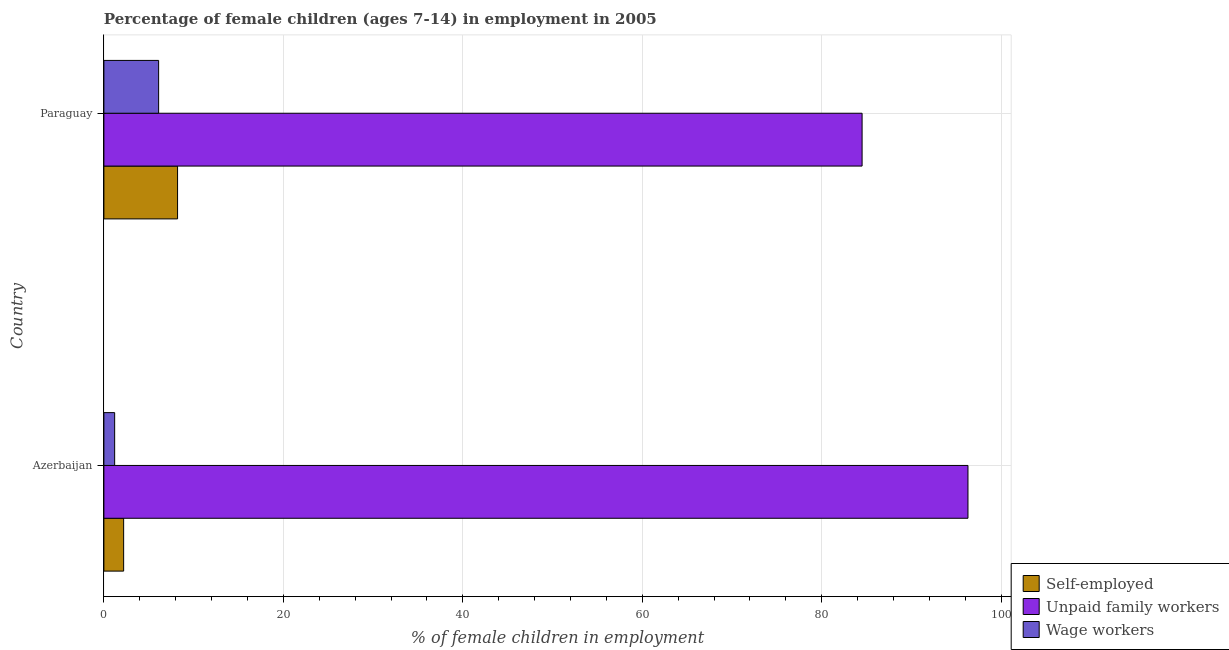How many different coloured bars are there?
Offer a very short reply. 3. How many groups of bars are there?
Keep it short and to the point. 2. Are the number of bars per tick equal to the number of legend labels?
Give a very brief answer. Yes. Are the number of bars on each tick of the Y-axis equal?
Provide a short and direct response. Yes. How many bars are there on the 1st tick from the bottom?
Your answer should be compact. 3. What is the label of the 2nd group of bars from the top?
Offer a very short reply. Azerbaijan. In how many cases, is the number of bars for a given country not equal to the number of legend labels?
Your answer should be compact. 0. What is the percentage of children employed as unpaid family workers in Azerbaijan?
Offer a very short reply. 96.3. Across all countries, what is the maximum percentage of children employed as unpaid family workers?
Make the answer very short. 96.3. Across all countries, what is the minimum percentage of children employed as unpaid family workers?
Provide a succinct answer. 84.5. In which country was the percentage of children employed as wage workers maximum?
Keep it short and to the point. Paraguay. In which country was the percentage of children employed as unpaid family workers minimum?
Offer a terse response. Paraguay. What is the difference between the percentage of self employed children in Azerbaijan and that in Paraguay?
Ensure brevity in your answer.  -6.01. What is the difference between the percentage of children employed as unpaid family workers in Azerbaijan and the percentage of children employed as wage workers in Paraguay?
Your response must be concise. 90.2. What is the average percentage of children employed as unpaid family workers per country?
Give a very brief answer. 90.4. What is the difference between the percentage of children employed as unpaid family workers and percentage of children employed as wage workers in Paraguay?
Your answer should be very brief. 78.4. In how many countries, is the percentage of self employed children greater than 48 %?
Provide a short and direct response. 0. What is the ratio of the percentage of children employed as wage workers in Azerbaijan to that in Paraguay?
Give a very brief answer. 0.2. Is the percentage of self employed children in Azerbaijan less than that in Paraguay?
Give a very brief answer. Yes. Is the difference between the percentage of self employed children in Azerbaijan and Paraguay greater than the difference between the percentage of children employed as unpaid family workers in Azerbaijan and Paraguay?
Offer a very short reply. No. In how many countries, is the percentage of children employed as wage workers greater than the average percentage of children employed as wage workers taken over all countries?
Provide a succinct answer. 1. What does the 3rd bar from the top in Azerbaijan represents?
Give a very brief answer. Self-employed. What does the 1st bar from the bottom in Paraguay represents?
Your response must be concise. Self-employed. How many bars are there?
Your answer should be compact. 6. Are all the bars in the graph horizontal?
Your answer should be compact. Yes. How many countries are there in the graph?
Ensure brevity in your answer.  2. Are the values on the major ticks of X-axis written in scientific E-notation?
Your answer should be compact. No. Does the graph contain any zero values?
Ensure brevity in your answer.  No. Does the graph contain grids?
Give a very brief answer. Yes. Where does the legend appear in the graph?
Give a very brief answer. Bottom right. How many legend labels are there?
Your answer should be compact. 3. How are the legend labels stacked?
Offer a very short reply. Vertical. What is the title of the graph?
Provide a short and direct response. Percentage of female children (ages 7-14) in employment in 2005. What is the label or title of the X-axis?
Give a very brief answer. % of female children in employment. What is the % of female children in employment in Unpaid family workers in Azerbaijan?
Your answer should be compact. 96.3. What is the % of female children in employment in Wage workers in Azerbaijan?
Make the answer very short. 1.2. What is the % of female children in employment of Self-employed in Paraguay?
Offer a terse response. 8.21. What is the % of female children in employment of Unpaid family workers in Paraguay?
Your answer should be compact. 84.5. What is the % of female children in employment in Wage workers in Paraguay?
Your answer should be very brief. 6.1. Across all countries, what is the maximum % of female children in employment of Self-employed?
Offer a terse response. 8.21. Across all countries, what is the maximum % of female children in employment in Unpaid family workers?
Give a very brief answer. 96.3. Across all countries, what is the minimum % of female children in employment of Self-employed?
Provide a succinct answer. 2.2. Across all countries, what is the minimum % of female children in employment of Unpaid family workers?
Offer a very short reply. 84.5. What is the total % of female children in employment of Self-employed in the graph?
Provide a short and direct response. 10.41. What is the total % of female children in employment in Unpaid family workers in the graph?
Keep it short and to the point. 180.8. What is the difference between the % of female children in employment in Self-employed in Azerbaijan and that in Paraguay?
Offer a very short reply. -6.01. What is the difference between the % of female children in employment of Unpaid family workers in Azerbaijan and that in Paraguay?
Ensure brevity in your answer.  11.8. What is the difference between the % of female children in employment of Wage workers in Azerbaijan and that in Paraguay?
Offer a terse response. -4.9. What is the difference between the % of female children in employment of Self-employed in Azerbaijan and the % of female children in employment of Unpaid family workers in Paraguay?
Offer a very short reply. -82.3. What is the difference between the % of female children in employment in Unpaid family workers in Azerbaijan and the % of female children in employment in Wage workers in Paraguay?
Your answer should be compact. 90.2. What is the average % of female children in employment in Self-employed per country?
Provide a succinct answer. 5.21. What is the average % of female children in employment in Unpaid family workers per country?
Your answer should be compact. 90.4. What is the average % of female children in employment of Wage workers per country?
Offer a terse response. 3.65. What is the difference between the % of female children in employment of Self-employed and % of female children in employment of Unpaid family workers in Azerbaijan?
Give a very brief answer. -94.1. What is the difference between the % of female children in employment of Unpaid family workers and % of female children in employment of Wage workers in Azerbaijan?
Provide a short and direct response. 95.1. What is the difference between the % of female children in employment in Self-employed and % of female children in employment in Unpaid family workers in Paraguay?
Keep it short and to the point. -76.29. What is the difference between the % of female children in employment of Self-employed and % of female children in employment of Wage workers in Paraguay?
Your answer should be compact. 2.11. What is the difference between the % of female children in employment in Unpaid family workers and % of female children in employment in Wage workers in Paraguay?
Offer a very short reply. 78.4. What is the ratio of the % of female children in employment in Self-employed in Azerbaijan to that in Paraguay?
Make the answer very short. 0.27. What is the ratio of the % of female children in employment in Unpaid family workers in Azerbaijan to that in Paraguay?
Provide a succinct answer. 1.14. What is the ratio of the % of female children in employment of Wage workers in Azerbaijan to that in Paraguay?
Keep it short and to the point. 0.2. What is the difference between the highest and the second highest % of female children in employment of Self-employed?
Make the answer very short. 6.01. What is the difference between the highest and the lowest % of female children in employment of Self-employed?
Your response must be concise. 6.01. What is the difference between the highest and the lowest % of female children in employment in Wage workers?
Your response must be concise. 4.9. 